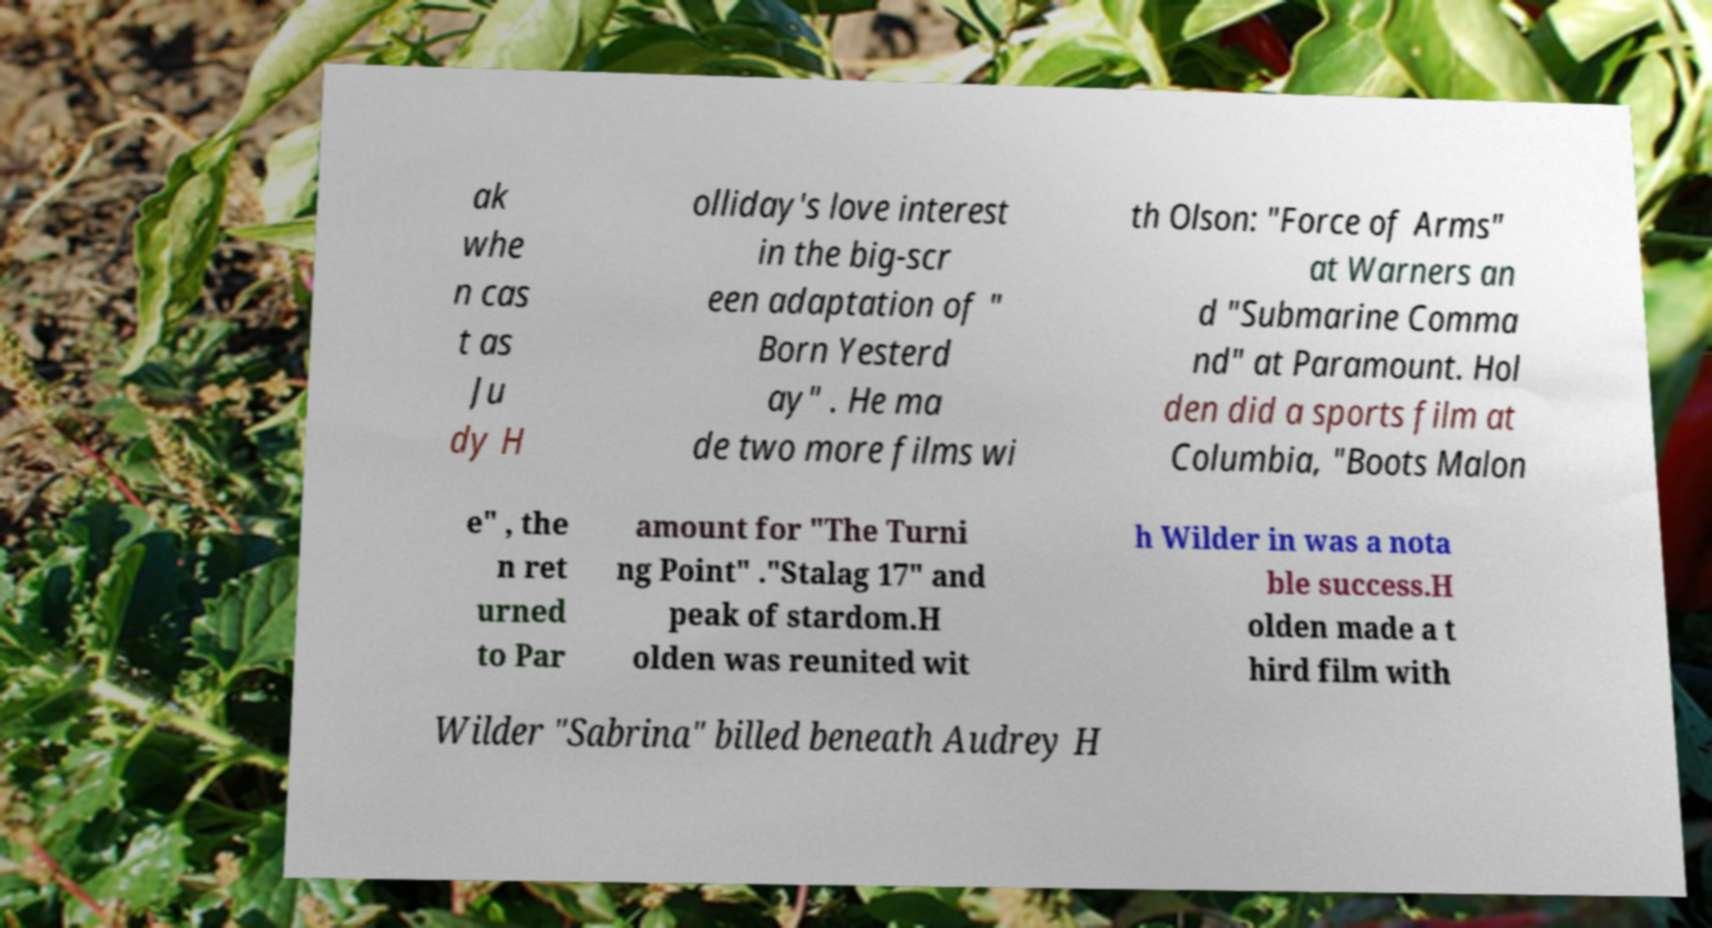What messages or text are displayed in this image? I need them in a readable, typed format. ak whe n cas t as Ju dy H olliday's love interest in the big-scr een adaptation of " Born Yesterd ay" . He ma de two more films wi th Olson: "Force of Arms" at Warners an d "Submarine Comma nd" at Paramount. Hol den did a sports film at Columbia, "Boots Malon e" , the n ret urned to Par amount for "The Turni ng Point" ."Stalag 17" and peak of stardom.H olden was reunited wit h Wilder in was a nota ble success.H olden made a t hird film with Wilder "Sabrina" billed beneath Audrey H 